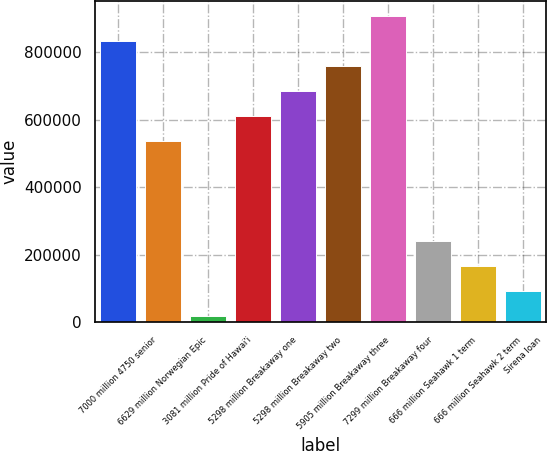Convert chart. <chart><loc_0><loc_0><loc_500><loc_500><bar_chart><fcel>7000 million 4750 senior<fcel>6629 million Norwegian Epic<fcel>3081 million Pride of Hawai'i<fcel>5298 million Breakaway one<fcel>5298 million Breakaway two<fcel>5905 million Breakaway three<fcel>7299 million Breakaway four<fcel>666 million Seahawk 1 term<fcel>666 million Seahawk 2 term<fcel>Sirena loan<nl><fcel>832611<fcel>536548<fcel>18438<fcel>610564<fcel>684579<fcel>758595<fcel>906626<fcel>240485<fcel>166469<fcel>92453.7<nl></chart> 